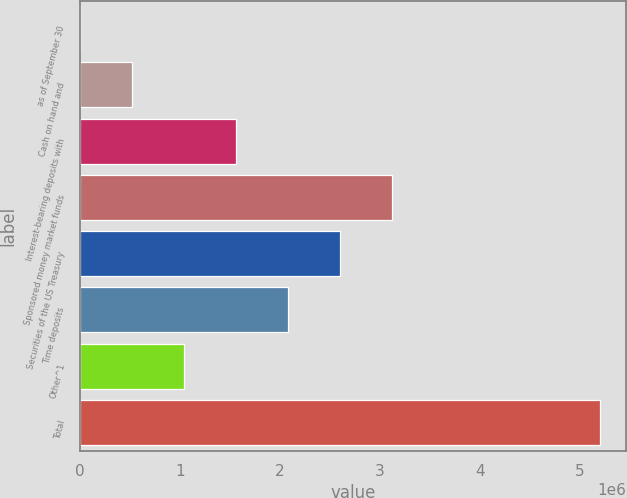<chart> <loc_0><loc_0><loc_500><loc_500><bar_chart><fcel>as of September 30<fcel>Cash on hand and<fcel>Interest-bearing deposits with<fcel>Sponsored money market funds<fcel>Securities of the US Treasury<fcel>Time deposits<fcel>Other^1<fcel>Total<nl><fcel>2011<fcel>521671<fcel>1.56099e+06<fcel>3.11997e+06<fcel>2.60031e+06<fcel>2.08065e+06<fcel>1.04133e+06<fcel>5.19861e+06<nl></chart> 